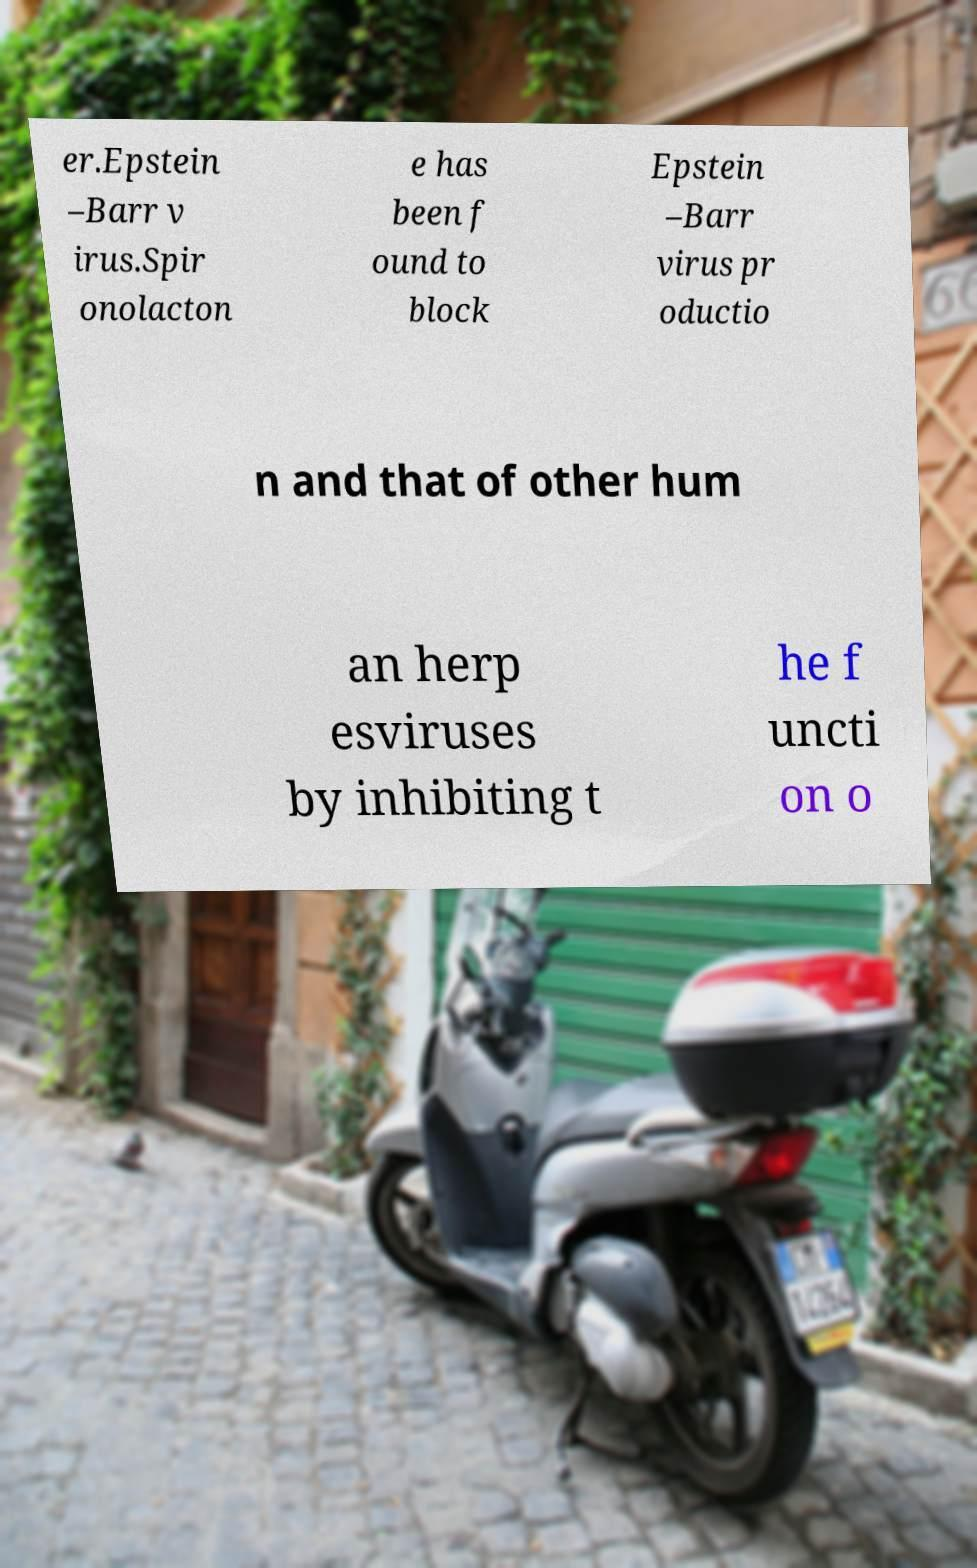Please identify and transcribe the text found in this image. er.Epstein –Barr v irus.Spir onolacton e has been f ound to block Epstein –Barr virus pr oductio n and that of other hum an herp esviruses by inhibiting t he f uncti on o 